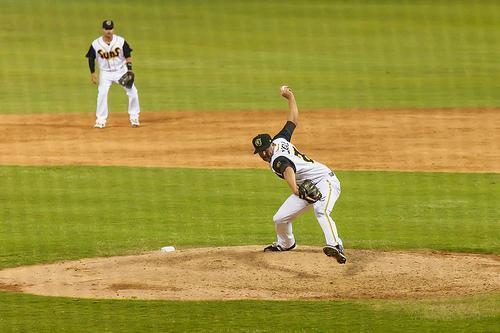How many balls are in the picture?
Give a very brief answer. 1. How many baseball caps are in the picture?
Give a very brief answer. 2. 